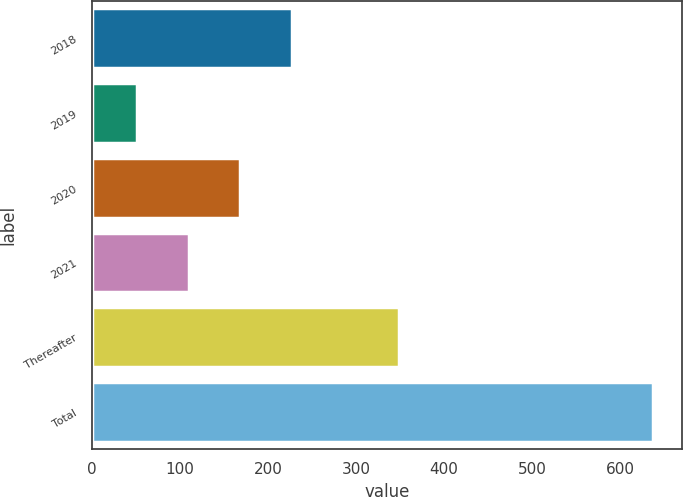Convert chart to OTSL. <chart><loc_0><loc_0><loc_500><loc_500><bar_chart><fcel>2018<fcel>2019<fcel>2020<fcel>2021<fcel>Thereafter<fcel>Total<nl><fcel>227.1<fcel>51<fcel>168.4<fcel>109.7<fcel>349<fcel>638<nl></chart> 